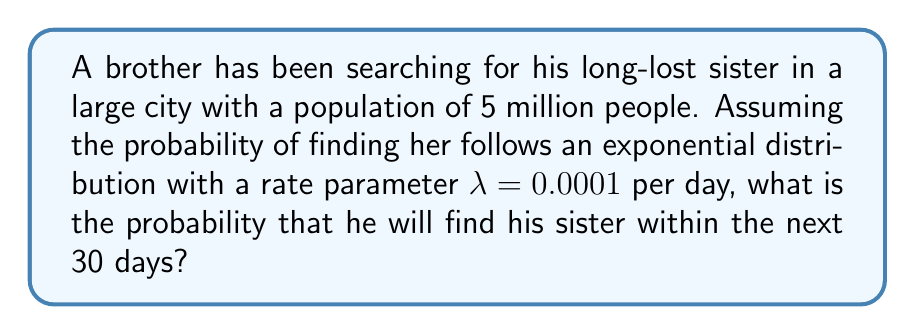Can you solve this math problem? To solve this problem, we need to use the cumulative distribution function (CDF) of the exponential distribution. The CDF of an exponential distribution is given by:

$$ F(t) = 1 - e^{-λt} $$

Where:
- $F(t)$ is the probability of the event occurring within time $t$
- $λ$ is the rate parameter
- $t$ is the time period

Given:
- λ = 0.0001 per day
- t = 30 days

Let's substitute these values into the CDF formula:

$$ F(30) = 1 - e^{-0.0001 * 30} $$

Now, let's calculate:

$$ F(30) = 1 - e^{-0.003} $$

Using a calculator or computer:

$$ F(30) = 1 - 0.9970044947 $$

$$ F(30) = 0.0029955053 $$

This can be expressed as a percentage:

$$ F(30) * 100\% = 0.2995505\% $$
Answer: The probability that the brother will find his sister within the next 30 days is approximately 0.2996% or 0.002996. 